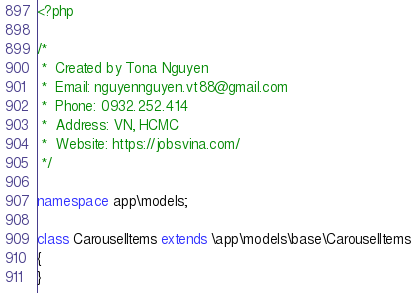<code> <loc_0><loc_0><loc_500><loc_500><_PHP_><?php

/*
 *  Created by Tona Nguyen
 *  Email: nguyennguyen.vt88@gmail.com
 *  Phone: 0932.252.414
 *  Address: VN, HCMC
 *  Website: https://jobsvina.com/
 */

namespace app\models;

class CarouselItems extends \app\models\base\CarouselItems
{
}
</code> 